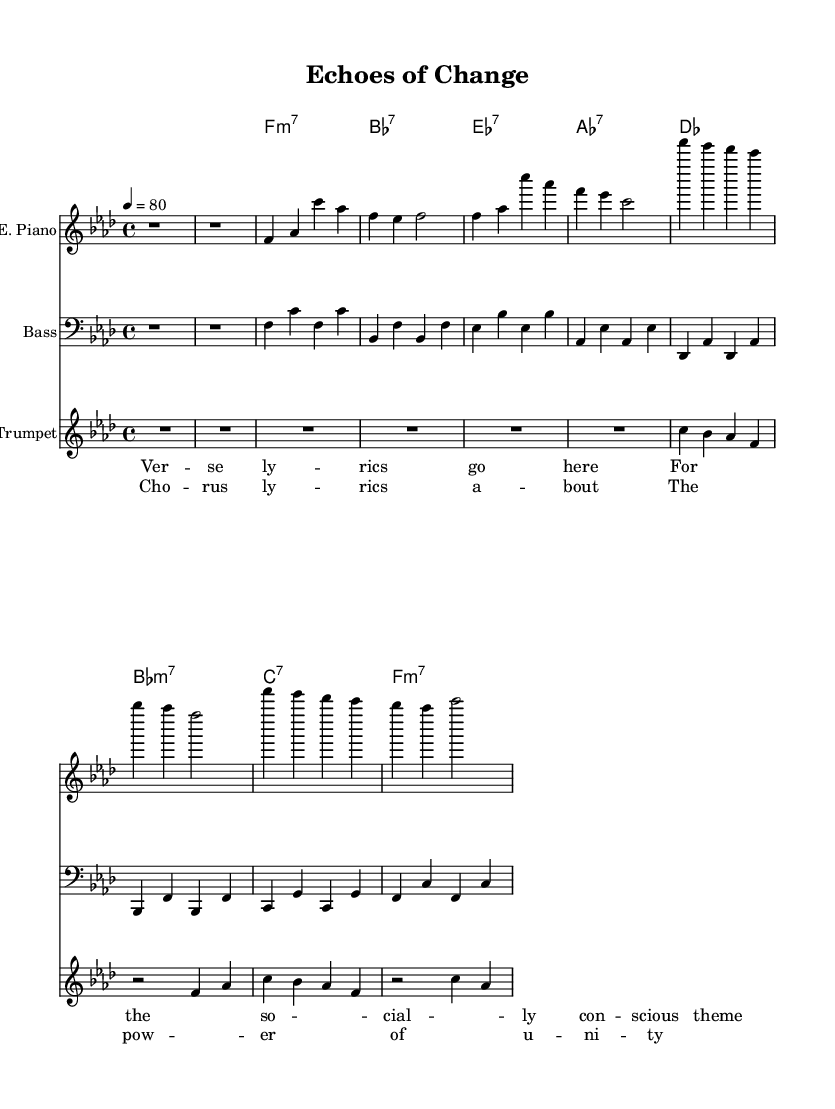What is the key signature of this music? The key signature is F minor, which contains four flats (B, E, A, D). This can be determined from the key signature indicated at the beginning of the score.
Answer: F minor What is the time signature of this music? The time signature is 4/4, denoting four beats per measure with a quarter note receiving one beat. This is stated at the beginning of the piece.
Answer: 4/4 What is the tempo marking of this piece? The tempo marking is 80 beats per minute as indicated by the tempo directive at the beginning of the score. This means the piece should be played at a moderate pace.
Answer: 80 How many measures are in the verse section? The verse section consists of 8 measures, which can be counted from the score where the verse is outlined. Each distinct line of music in the verse indicates a measure.
Answer: 8 What type of chord is used in the chorus? The chorus features primarily seventh chords, characterized by the inclusion of a seventh interval. This can be seen in the chord names listed above the melody in the score.
Answer: Seventh chords What instrument features a clef that indicates lower pitch range? The bass guitar features a bass clef, which indicates that the notes are played in a lower pitch range compared to treble clef instruments. This is evident from the clef symbol at the start of the bass guitar staff.
Answer: Bass clef What lyrical theme is conveyed in the chorus? The chorus lyrically emphasizes the power of unity, reflecting a socially conscious message which aligns with the overall theme of the piece. This can be derived from the lyrics inscribed above the musical notes in the chorus section.
Answer: Power of unity 